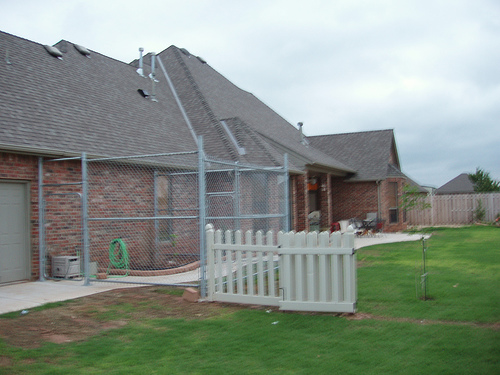<image>
Is there a fence above the fence? No. The fence is not positioned above the fence. The vertical arrangement shows a different relationship. 